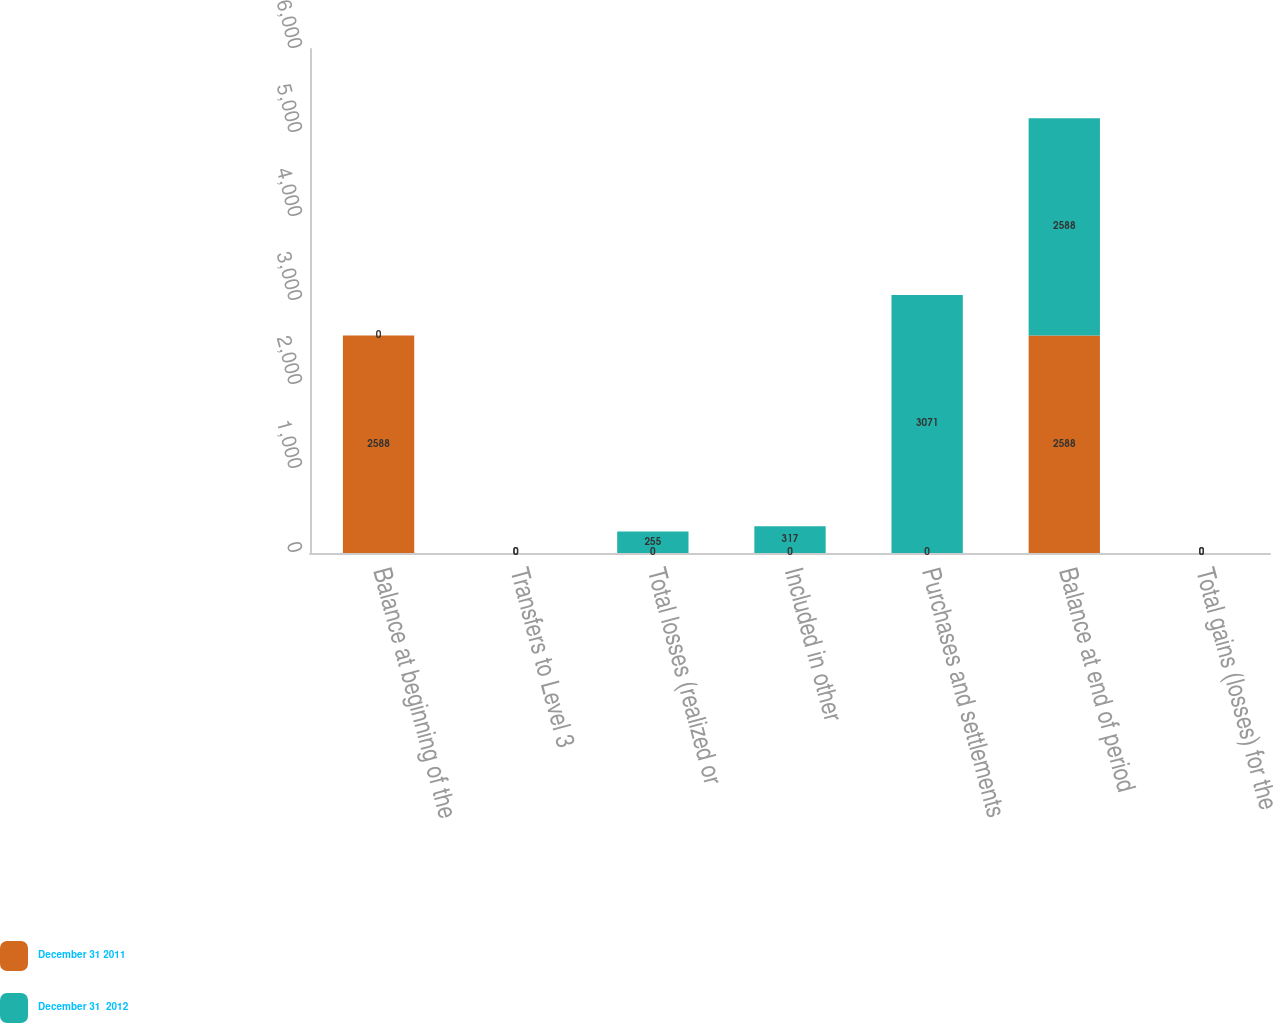Convert chart. <chart><loc_0><loc_0><loc_500><loc_500><stacked_bar_chart><ecel><fcel>Balance at beginning of the<fcel>Transfers to Level 3<fcel>Total losses (realized or<fcel>Included in other<fcel>Purchases and settlements<fcel>Balance at end of period<fcel>Total gains (losses) for the<nl><fcel>December 31 2011<fcel>2588<fcel>0<fcel>0<fcel>0<fcel>0<fcel>2588<fcel>0<nl><fcel>December 31  2012<fcel>0<fcel>0<fcel>255<fcel>317<fcel>3071<fcel>2588<fcel>0<nl></chart> 